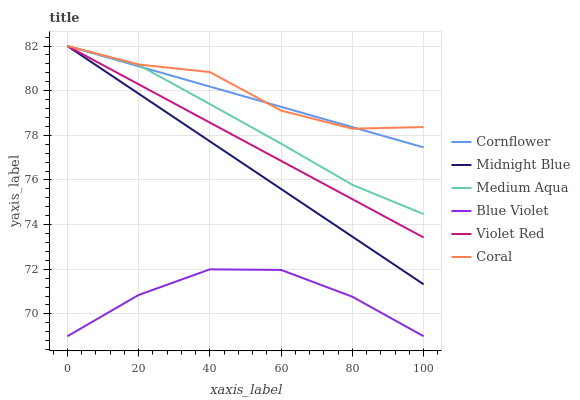Does Blue Violet have the minimum area under the curve?
Answer yes or no. Yes. Does Coral have the maximum area under the curve?
Answer yes or no. Yes. Does Violet Red have the minimum area under the curve?
Answer yes or no. No. Does Violet Red have the maximum area under the curve?
Answer yes or no. No. Is Cornflower the smoothest?
Answer yes or no. Yes. Is Coral the roughest?
Answer yes or no. Yes. Is Violet Red the smoothest?
Answer yes or no. No. Is Violet Red the roughest?
Answer yes or no. No. Does Blue Violet have the lowest value?
Answer yes or no. Yes. Does Violet Red have the lowest value?
Answer yes or no. No. Does Medium Aqua have the highest value?
Answer yes or no. Yes. Does Blue Violet have the highest value?
Answer yes or no. No. Is Blue Violet less than Violet Red?
Answer yes or no. Yes. Is Violet Red greater than Blue Violet?
Answer yes or no. Yes. Does Cornflower intersect Violet Red?
Answer yes or no. Yes. Is Cornflower less than Violet Red?
Answer yes or no. No. Is Cornflower greater than Violet Red?
Answer yes or no. No. Does Blue Violet intersect Violet Red?
Answer yes or no. No. 